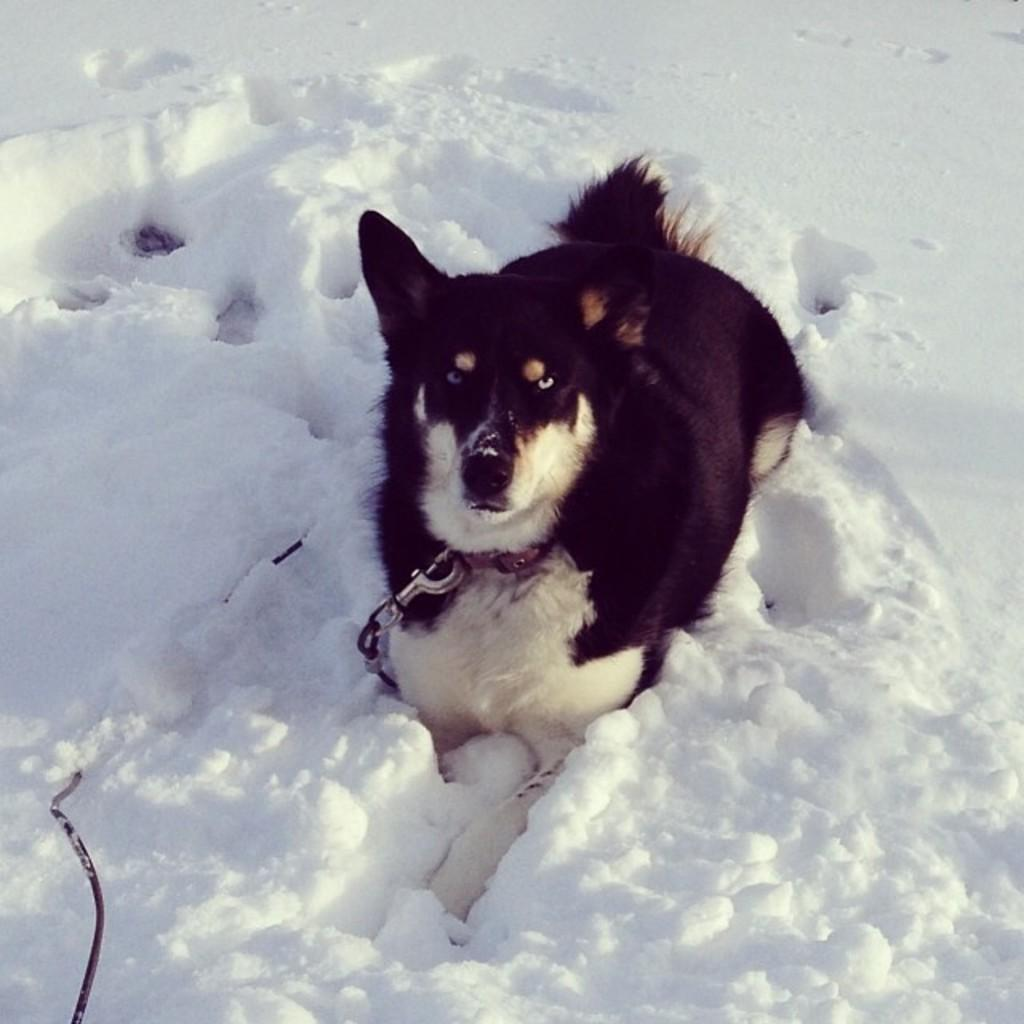What is the main subject in the center of the image? There is a dog in the center of the image. What type of weather is depicted in the image? There is snow at the bottom of the image. What rhythm is the dog dancing to in the image? There is no indication in the image that the dog is dancing or following a rhythm. 